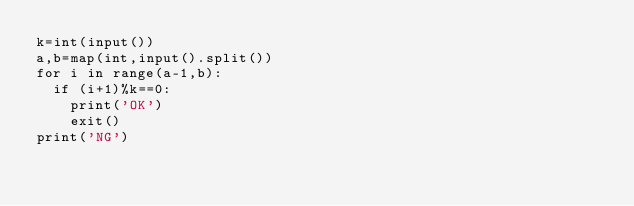Convert code to text. <code><loc_0><loc_0><loc_500><loc_500><_Python_>k=int(input())
a,b=map(int,input().split())
for i in range(a-1,b):
  if (i+1)%k==0:
    print('OK')
    exit()
print('NG')</code> 